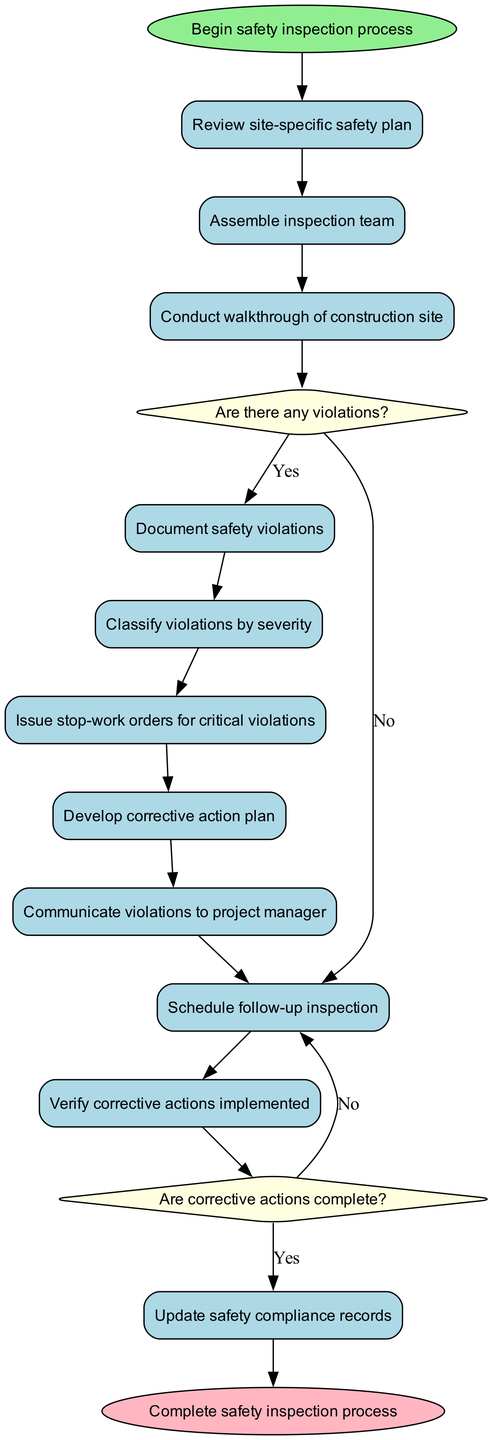What is the starting point of the diagram? The starting point, or the first node in the activity diagram, is labeled "Begin safety inspection process."
Answer: Begin safety inspection process How many activities are listed in the diagram? There are a total of ten activities that need to be performed according to the diagram.
Answer: 10 What happens after the "Conduct walkthrough of construction site" activity if there are violations? If there are violations after conducting the walkthrough, the flow goes from "Conduct walkthrough of construction site" to the decision node "Are there any violations?"
Answer: "Are there any violations?" What is the end point of the diagram? The end point of the diagram is indicated by the node labeled "Complete safety inspection process."
Answer: Complete safety inspection process What is issued for critical violations? For critical violations, a "stop-work order" is issued according to the flow of the activities in the diagram.
Answer: Stop-work order What is the path taken if corrective actions are not complete after verification? If the corrective actions are not complete after verification, the flow directs back to "Schedule follow-up inspection," indicating the need for further action.
Answer: Schedule follow-up inspection How many decision nodes are present in the diagram? There are two decision nodes present in the diagram, with questions about violations and completeness of corrective actions.
Answer: 2 What action follows the "Develop corrective action plan" activity? The action that follows "Develop corrective action plan" is "Communicate violations to project manager."
Answer: Communicate violations to project manager What determines whether to issue a stop-work order? The decision to issue a stop-work order is based on the severity of the violations after classifying them.
Answer: Severity of violations 